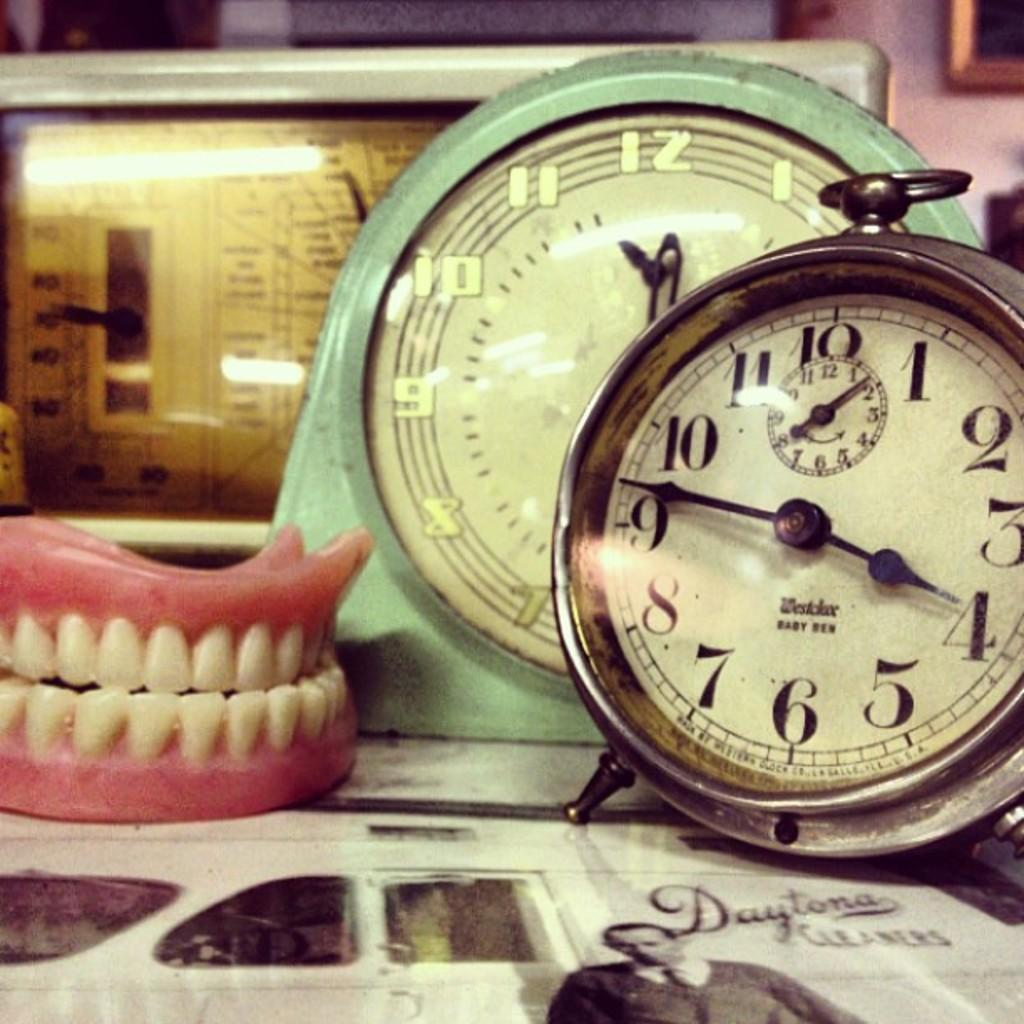Provide a one-sentence caption for the provided image. A couple of clocks to the right of a fake set of teeth. 